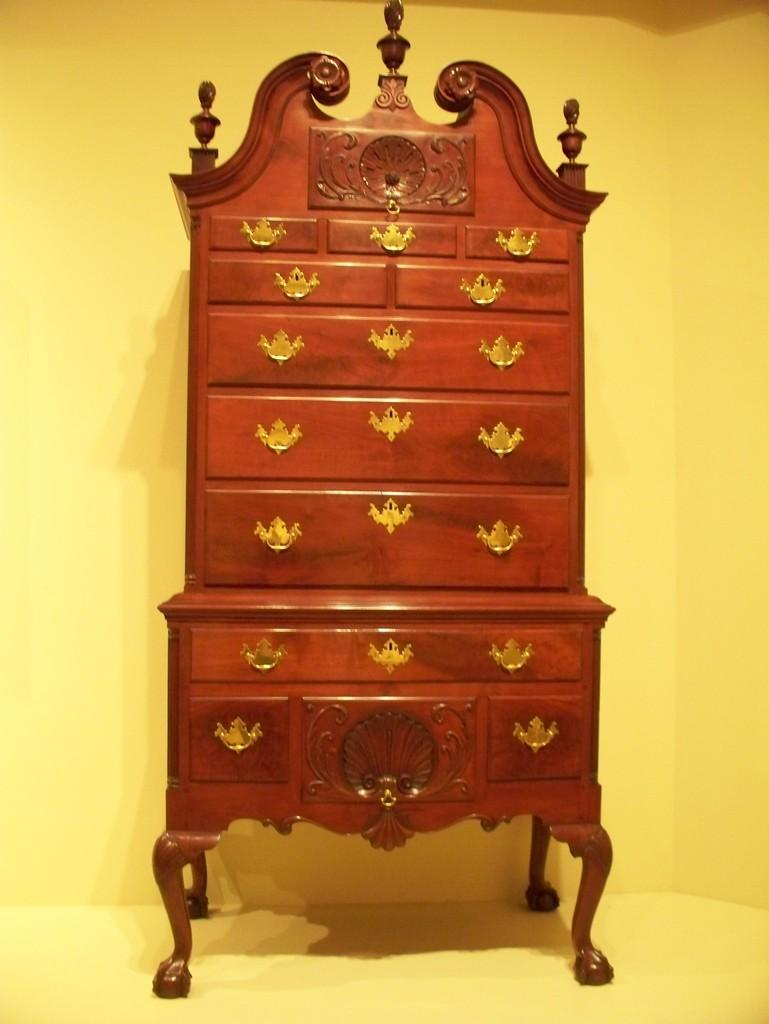What piece of furniture is present in the image? There is a table in the image. What color is the background of the image? The background of the image is yellow. How many dimes are on the table in the image? There is no mention of dimes in the image, so we cannot determine their presence or quantity. 